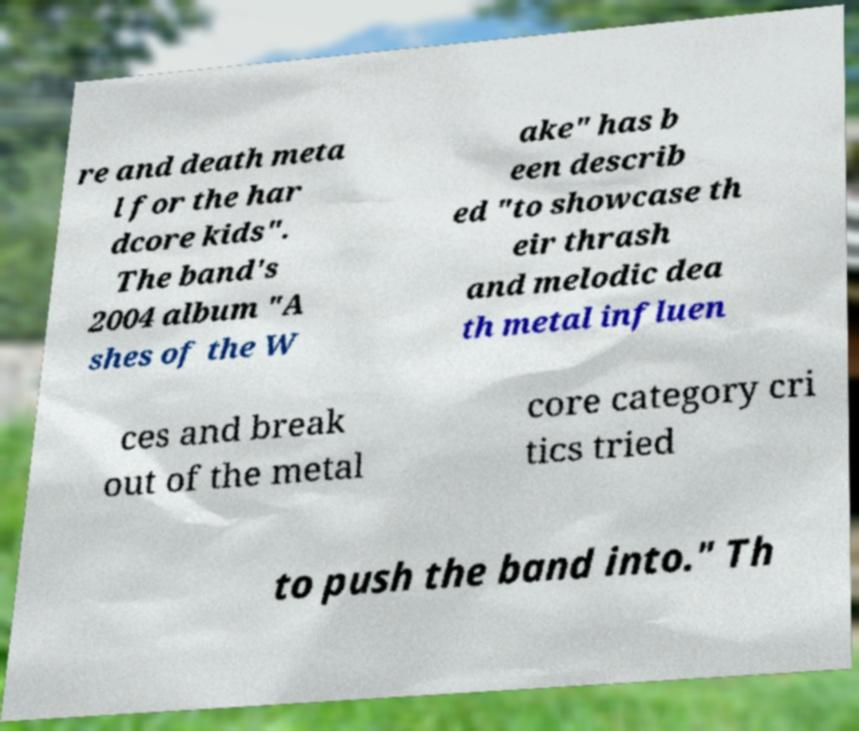There's text embedded in this image that I need extracted. Can you transcribe it verbatim? re and death meta l for the har dcore kids". The band's 2004 album "A shes of the W ake" has b een describ ed "to showcase th eir thrash and melodic dea th metal influen ces and break out of the metal core category cri tics tried to push the band into." Th 